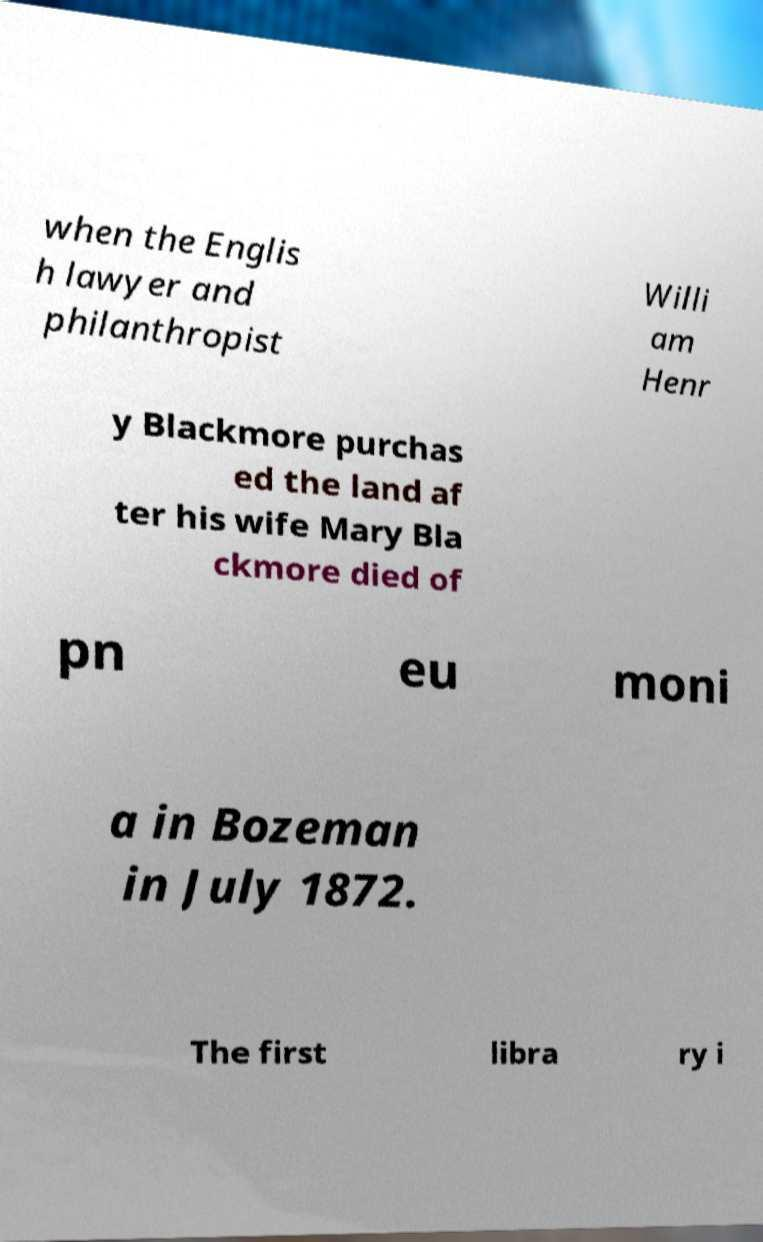For documentation purposes, I need the text within this image transcribed. Could you provide that? when the Englis h lawyer and philanthropist Willi am Henr y Blackmore purchas ed the land af ter his wife Mary Bla ckmore died of pn eu moni a in Bozeman in July 1872. The first libra ry i 